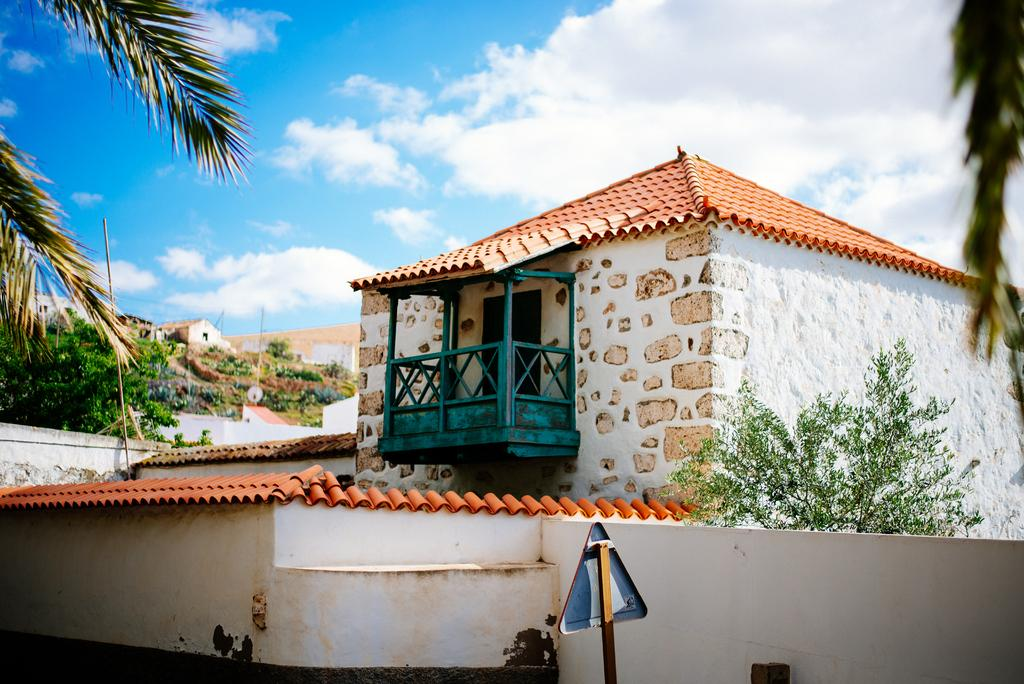What can be seen in the sky in the image? The sky with clouds is visible in the image. What type of natural elements are present in the image? There are trees and plants visible in the image. What type of man-made structures can be seen in the image? There are buildings and sign boards present in the image. What might be used for cooking in the image? Grills are present in the image. Can you hear the bells ringing in the image? There are no bells present in the image, so it is not possible to hear them ringing. What subject is being taught in the image? There is no teaching or educational activity depicted in the image. 